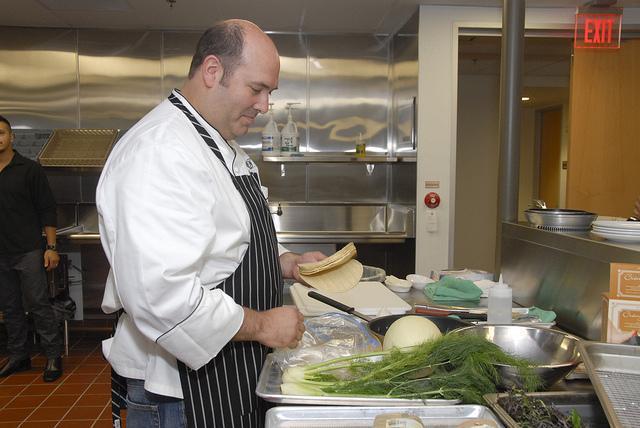How many people are men?
Give a very brief answer. 2. How many people are there?
Give a very brief answer. 2. How many sandwiches are on the plate?
Give a very brief answer. 0. 